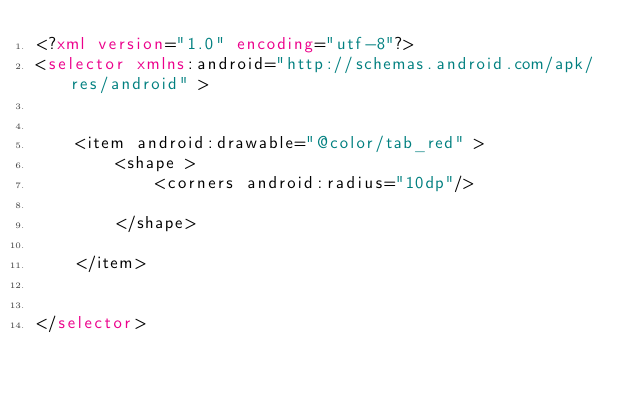Convert code to text. <code><loc_0><loc_0><loc_500><loc_500><_XML_><?xml version="1.0" encoding="utf-8"?>
<selector xmlns:android="http://schemas.android.com/apk/res/android" >
    
  
    <item android:drawable="@color/tab_red" >
        <shape >
            <corners android:radius="10dp"/>
            	
        </shape>
        
    </item>

  
</selector>
</code> 